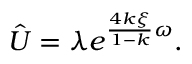Convert formula to latex. <formula><loc_0><loc_0><loc_500><loc_500>\hat { U } = \lambda e ^ { \frac { 4 k \xi } { 1 - k } \omega } .</formula> 